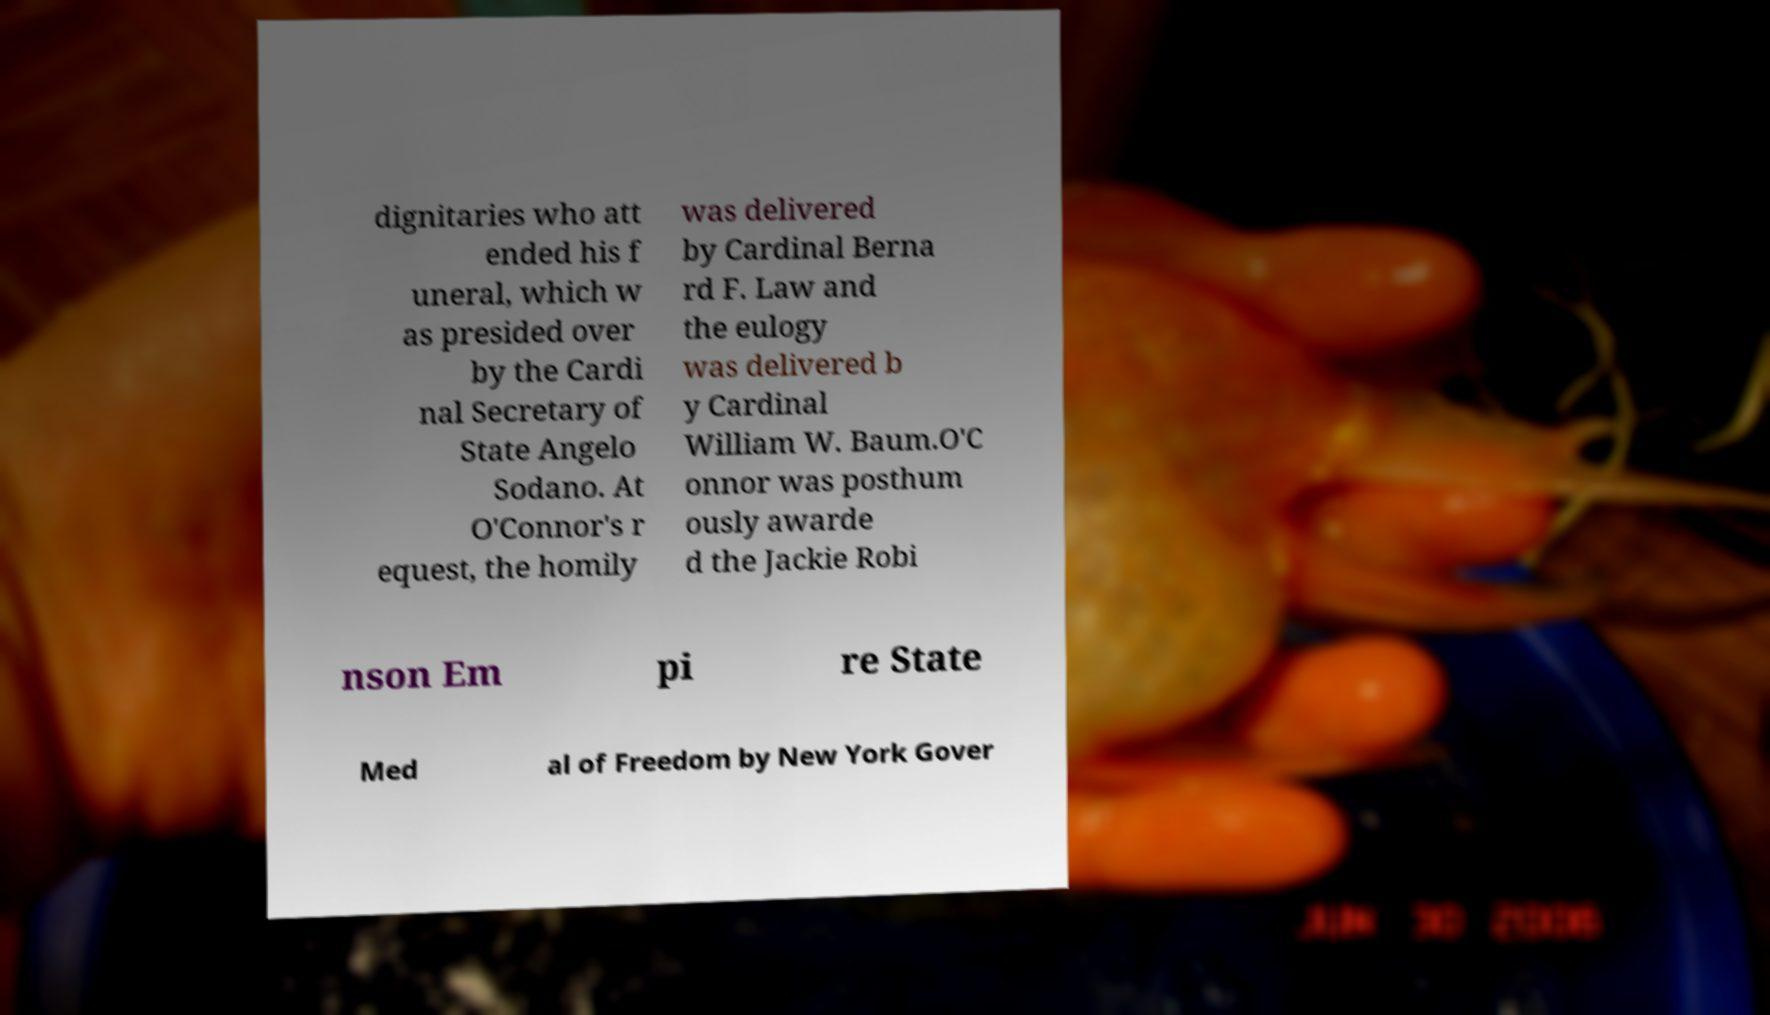Please identify and transcribe the text found in this image. dignitaries who att ended his f uneral, which w as presided over by the Cardi nal Secretary of State Angelo Sodano. At O'Connor's r equest, the homily was delivered by Cardinal Berna rd F. Law and the eulogy was delivered b y Cardinal William W. Baum.O'C onnor was posthum ously awarde d the Jackie Robi nson Em pi re State Med al of Freedom by New York Gover 